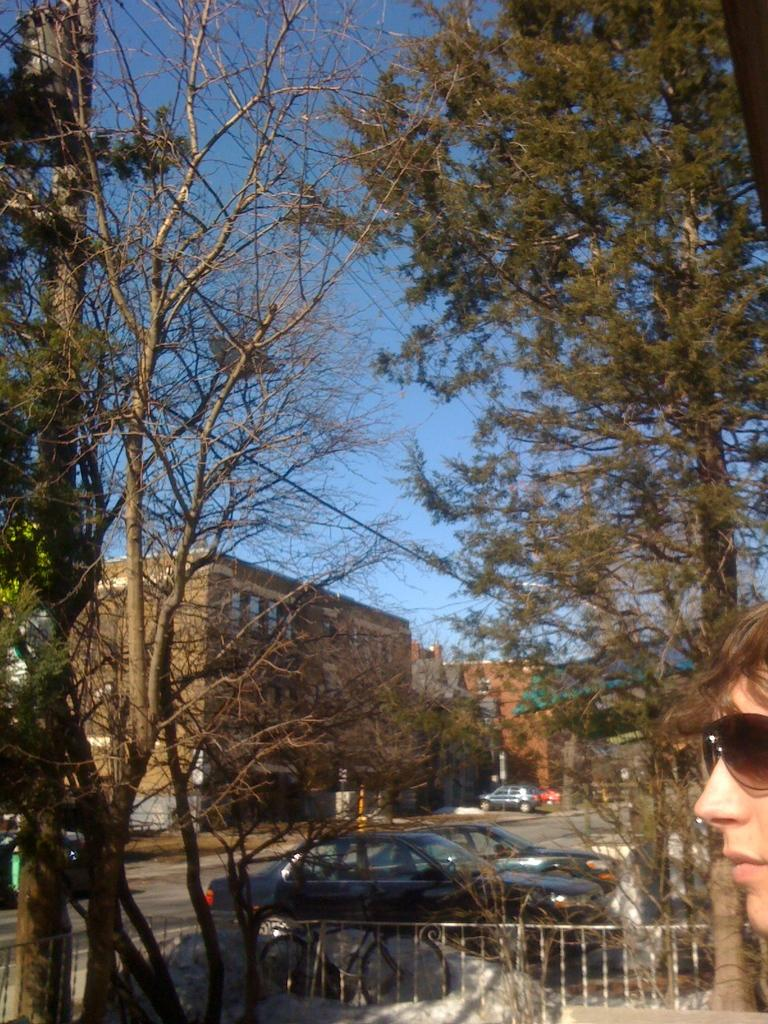What is on the road in the image? There is a vehicle on the road in the image. Can you describe any human features in the image? Yes, there is a person's face visible in the image. What type of vegetation can be seen in the background of the image? There are trees in the background of the image, and they are green. What type of structure is visible in the background of the image? There is a building in the background of the image, and it is brown. What is the color of the sky in the image? The sky is visible in the image, and it is blue. What type of insurance is required for the vehicle in the image? There is no information about insurance in the image, so it cannot be determined. What religious belief does the person in the image follow? There is no information about the person's religious beliefs in the image, so it cannot be determined. 